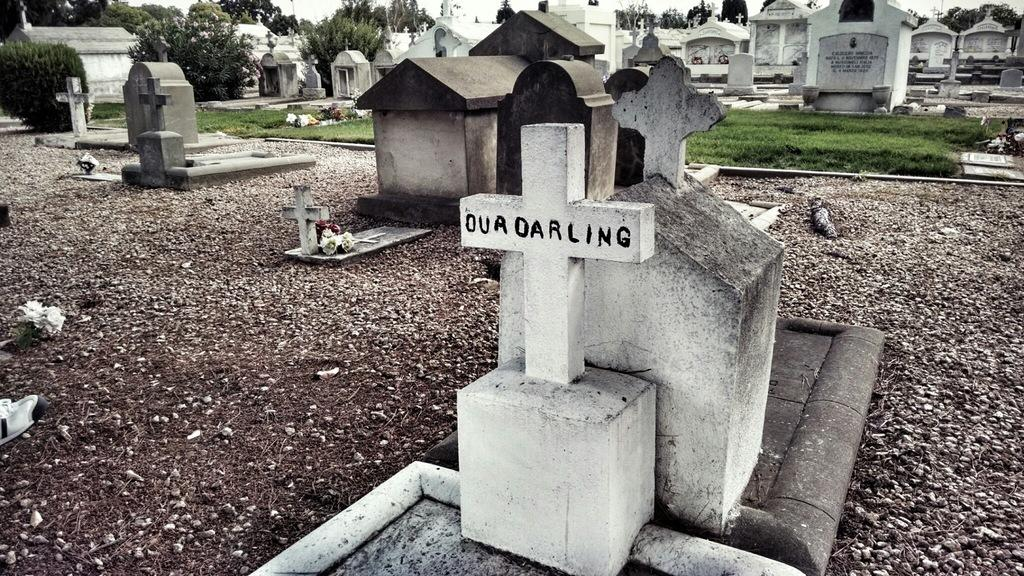What type of vegetation can be seen in the image? There are trees and grass in the image. What is the setting of the image? The image features a graveyard. Are there any decorative elements in the image? Yes, there are flowers in the image. What can be seen on the ground in the image? The ground is visible in the image, and there may be objects present as well. Can you see any friends interacting with the giants in the image? There are no giants or friends present in the image. What type of industry is depicted in the image? There is no industry present in the image; it features a graveyard, trees, grass, flowers, objects, and the ground. 